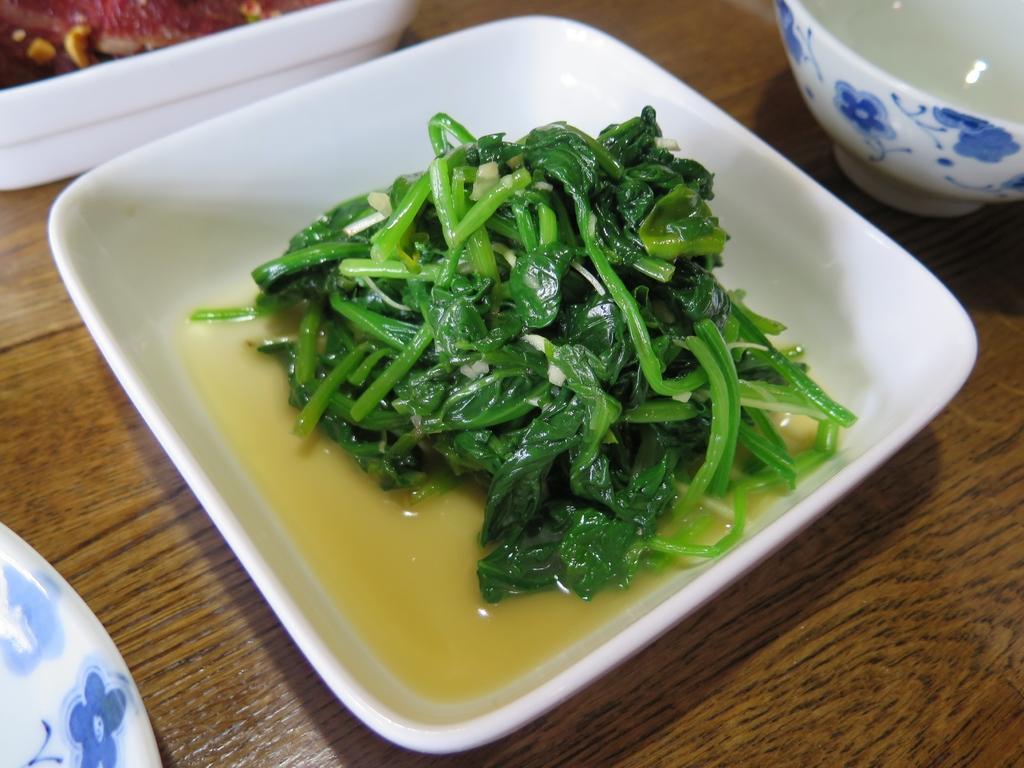How would you summarize this image in a sentence or two? In the image on the wooden surface there is a bowl with a food item in it. And also there are few bowls and some other things on it. 